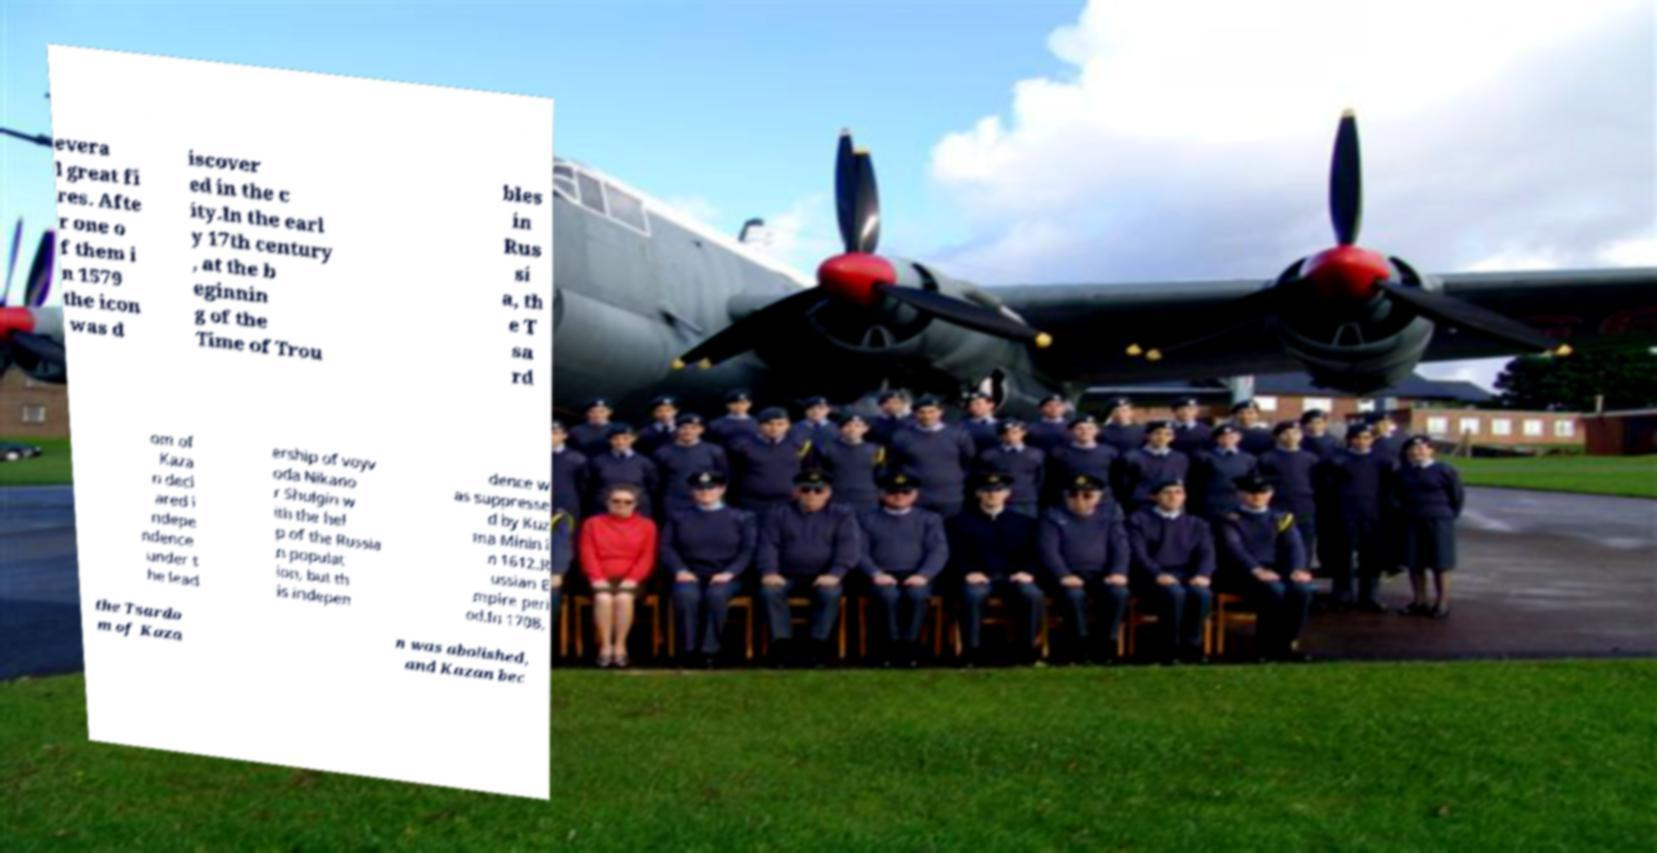Please identify and transcribe the text found in this image. evera l great fi res. Afte r one o f them i n 1579 the icon was d iscover ed in the c ity.In the earl y 17th century , at the b eginnin g of the Time of Trou bles in Rus si a, th e T sa rd om of Kaza n decl ared i ndepe ndence under t he lead ership of voyv oda Nikano r Shulgin w ith the hel p of the Russia n populat ion, but th is indepen dence w as suppresse d by Kuz ma Minin i n 1612.R ussian E mpire peri od.In 1708, the Tsardo m of Kaza n was abolished, and Kazan bec 